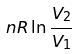<formula> <loc_0><loc_0><loc_500><loc_500>n R \ln \frac { V _ { 2 } } { V _ { 1 } }</formula> 